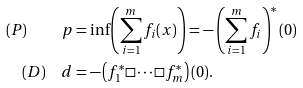<formula> <loc_0><loc_0><loc_500><loc_500>( P ) \quad p & = \inf \left ( \sum _ { i = 1 } ^ { m } f _ { i } ( x ) \right ) = - \left ( \sum _ { i = 1 } ^ { m } f _ { i } \right ) ^ { * } ( 0 ) \\ ( D ) \quad d & = - \left ( f ^ { * } _ { 1 } \Box \cdots \Box f ^ { * } _ { m } \right ) ( 0 ) .</formula> 